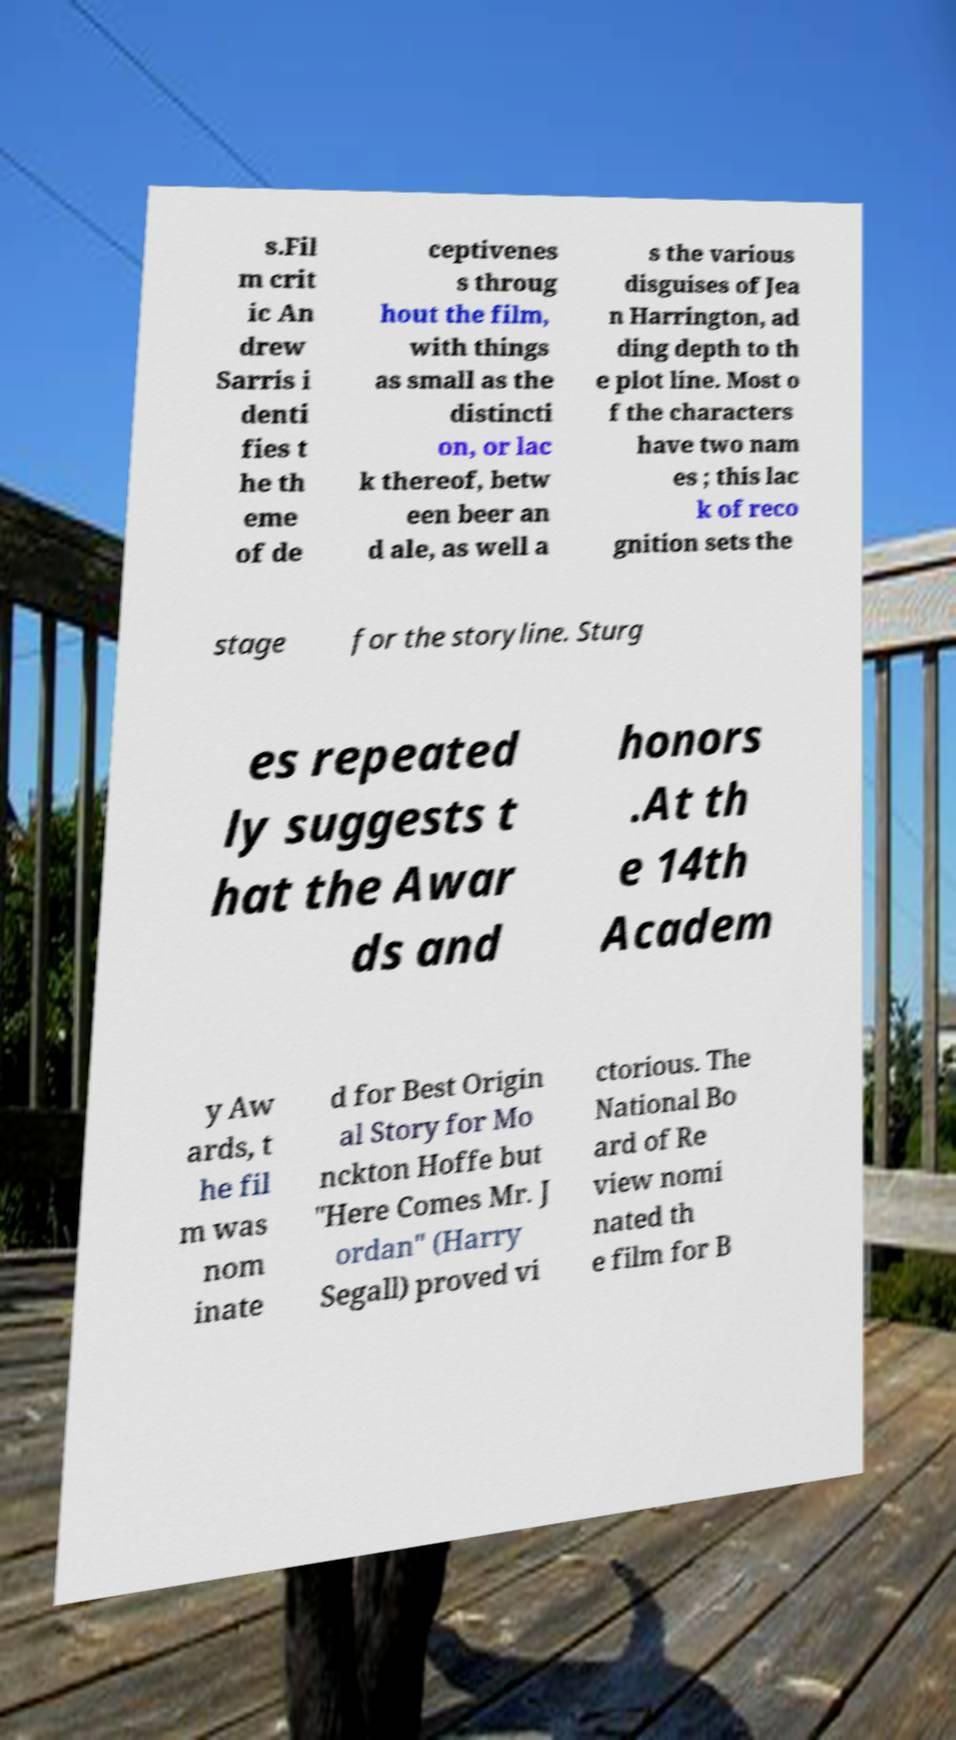Can you read and provide the text displayed in the image?This photo seems to have some interesting text. Can you extract and type it out for me? s.Fil m crit ic An drew Sarris i denti fies t he th eme of de ceptivenes s throug hout the film, with things as small as the distincti on, or lac k thereof, betw een beer an d ale, as well a s the various disguises of Jea n Harrington, ad ding depth to th e plot line. Most o f the characters have two nam es ; this lac k of reco gnition sets the stage for the storyline. Sturg es repeated ly suggests t hat the Awar ds and honors .At th e 14th Academ y Aw ards, t he fil m was nom inate d for Best Origin al Story for Mo nckton Hoffe but "Here Comes Mr. J ordan" (Harry Segall) proved vi ctorious. The National Bo ard of Re view nomi nated th e film for B 